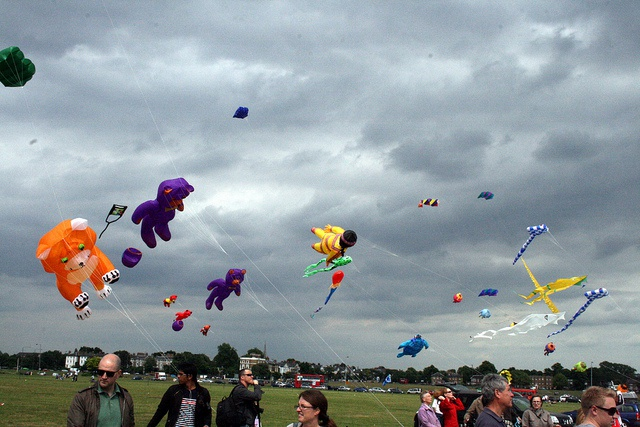Describe the objects in this image and their specific colors. I can see kite in darkgray, lightgray, and black tones, kite in darkgray, red, brown, and orange tones, car in darkgray, black, gray, darkgreen, and maroon tones, people in darkgray, black, teal, and maroon tones, and people in darkgray, black, maroon, and gray tones in this image. 